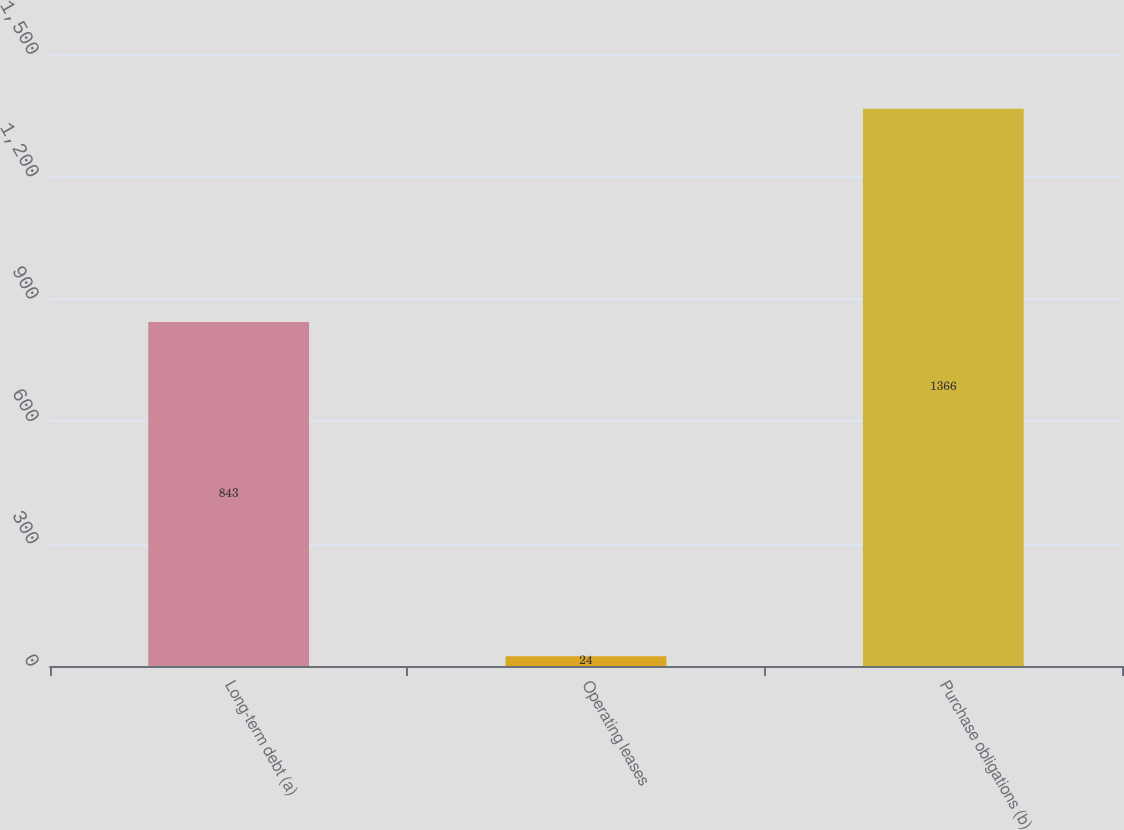<chart> <loc_0><loc_0><loc_500><loc_500><bar_chart><fcel>Long-term debt (a)<fcel>Operating leases<fcel>Purchase obligations (b)<nl><fcel>843<fcel>24<fcel>1366<nl></chart> 